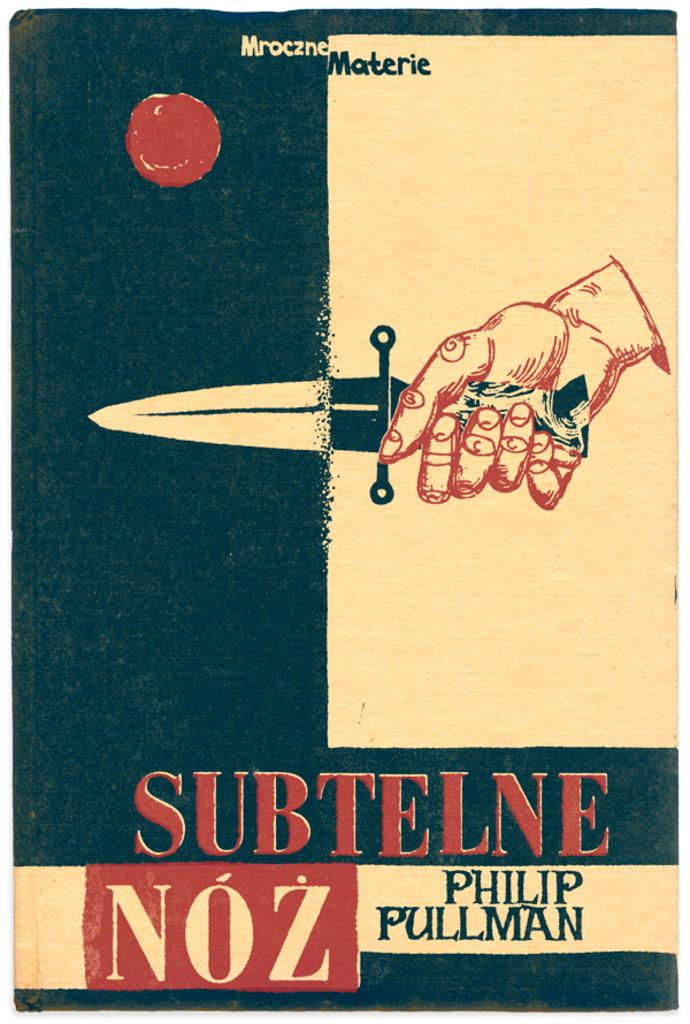<image>
Create a compact narrative representing the image presented. Advertising in a different language that includes a hand holding a knife or small sword. 